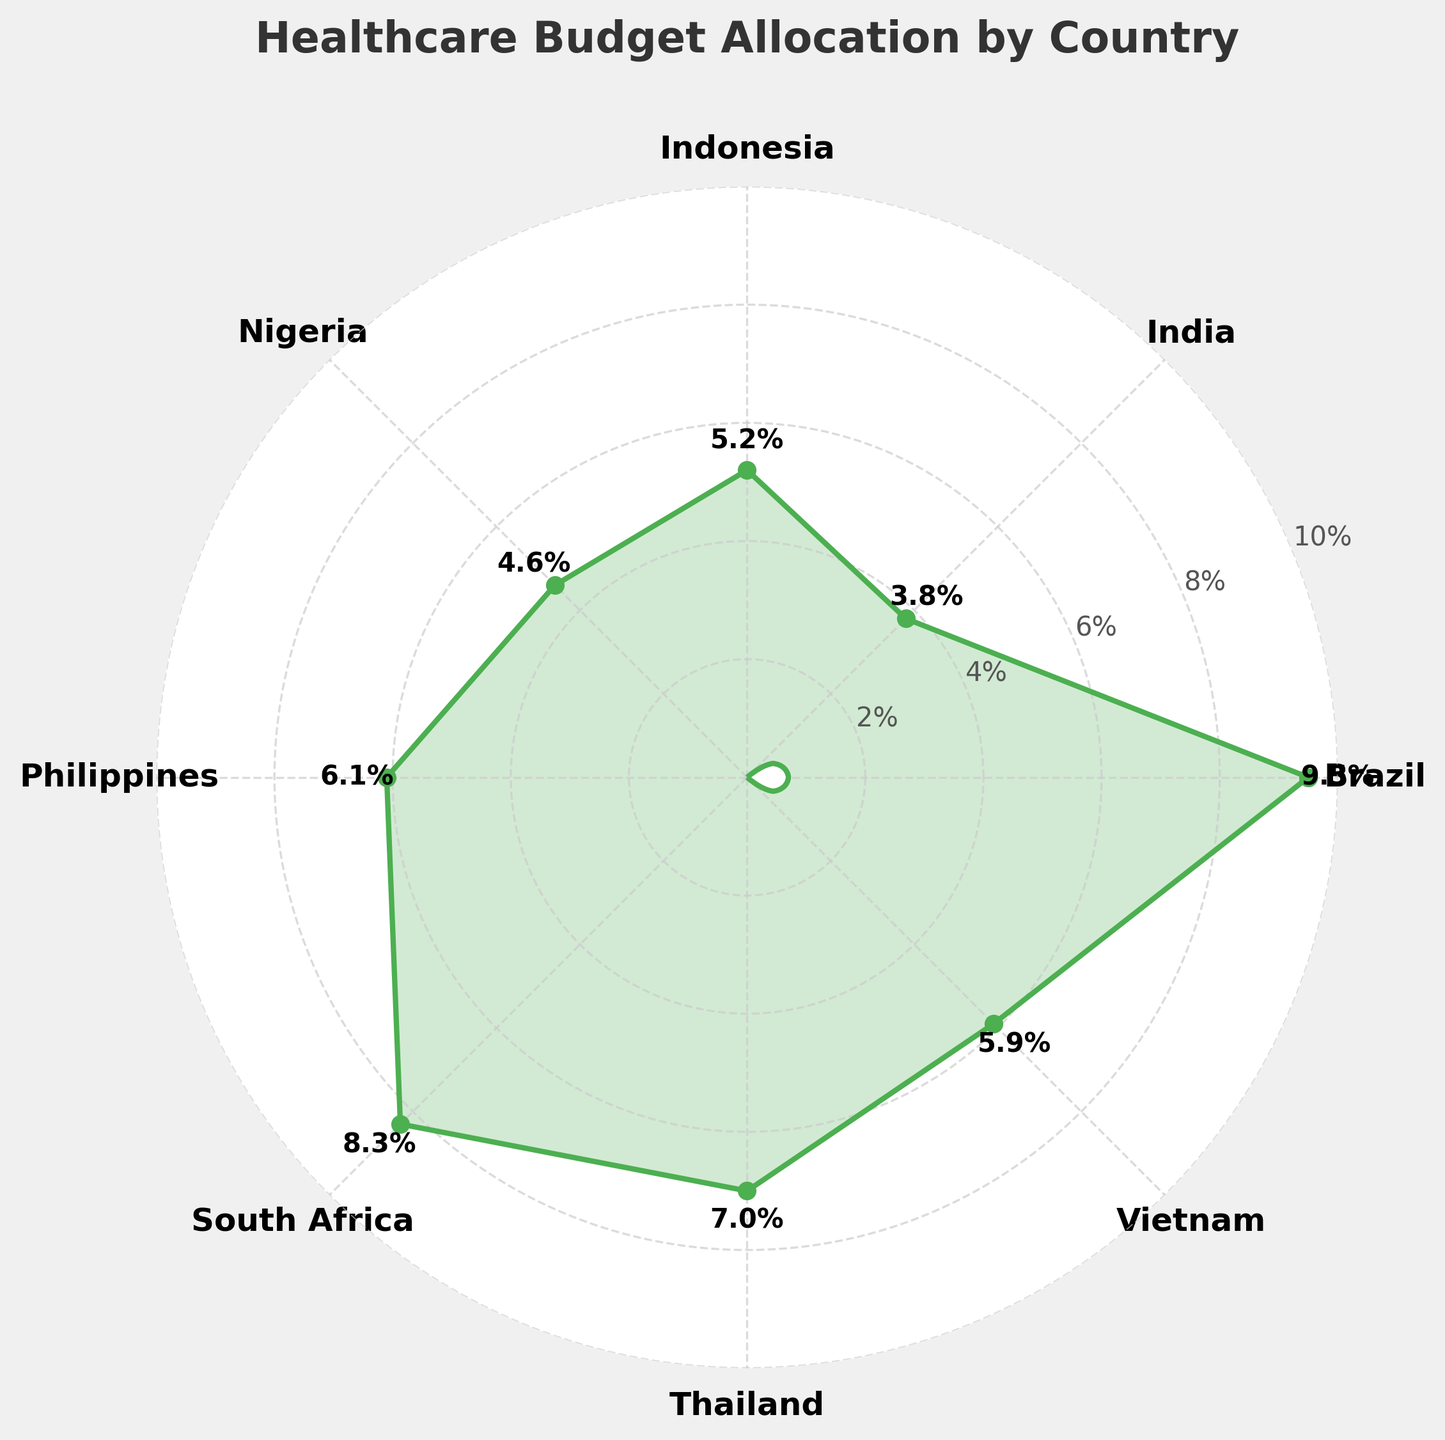What's the percentage of the annual budget allocated to healthcare in Brazil? The figure shows a gauge chart with each country's percentage marked. Find the label for Brazil and read the corresponding percentage: 9.5%
Answer: 9.5% Which country allocates the least percentage of its annual budget to healthcare? Identify the smallest percentage from the visual labels around the chart. India has the lowest value at 3.8%
Answer: India What's the average percentage allocated to healthcare among all countries listed? Sum all percentages: (9.5 + 3.8 + 5.2 + 4.6 + 6.1 + 8.3 + 7.0 + 5.9) = 50.4. Divide by 8 (number of countries): 50.4 / 8 = 6.3
Answer: 6.3 How does India's healthcare budget allocation compare to Nigeria's? Check India's percentage (3.8%) and Nigeria's percentage (4.6%). India allocates a smaller percentage than Nigeria
Answer: India allocates less Which country has a healthcare allocation closest to 6%? Locate the nearest percentage to 6% in the figure. The Philippines allocates 6.1%, the closest to 6%
Answer: Philippines What is the total percentage of the budget spent on healthcare by South Africa and Thailand combined? Look at the percentages for South Africa (8.3%) and Thailand (7.0%). Sum them: 8.3 + 7.0 = 15.3
Answer: 15.3 Identify two countries that allocate a similar percentage to healthcare as Vietnam. Vietnam's percentage is 5.9%. The figure shows Indonesia at 5.2% and the Philippines at 6.1%, which are closest to Vietnam's percentage
Answer: Indonesia and Philippines How many countries allocate more than 5% of their budget to healthcare? Count the countries with percentages greater than 5%. Brazil, Indonesia, Philippines, South Africa, Thailand, and Vietnam meet this criterion, totaling 6 countries
Answer: 6 Which country has the highest percentage allocation, and by how much is it higher than Thailand's allocation? Brazil has the highest at 9.5%. Thailand allocates 7.0%. The difference is 9.5 - 7.0 = 2.5
Answer: Brazil, 2.5 